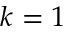Convert formula to latex. <formula><loc_0><loc_0><loc_500><loc_500>k = 1</formula> 